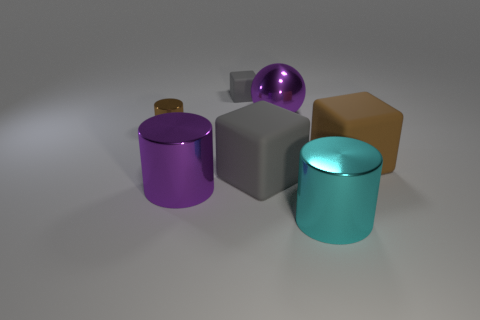Can you describe the textures of the objects shown? Certainly! The objects in the image vary in texture. The purple and teal cylinders seem to have a smooth, glossy texture, while the small brown object has a non-reflective, matte finish. The silver sphere and cube have highly reflective surfaces, suggesting a metallic texture. 